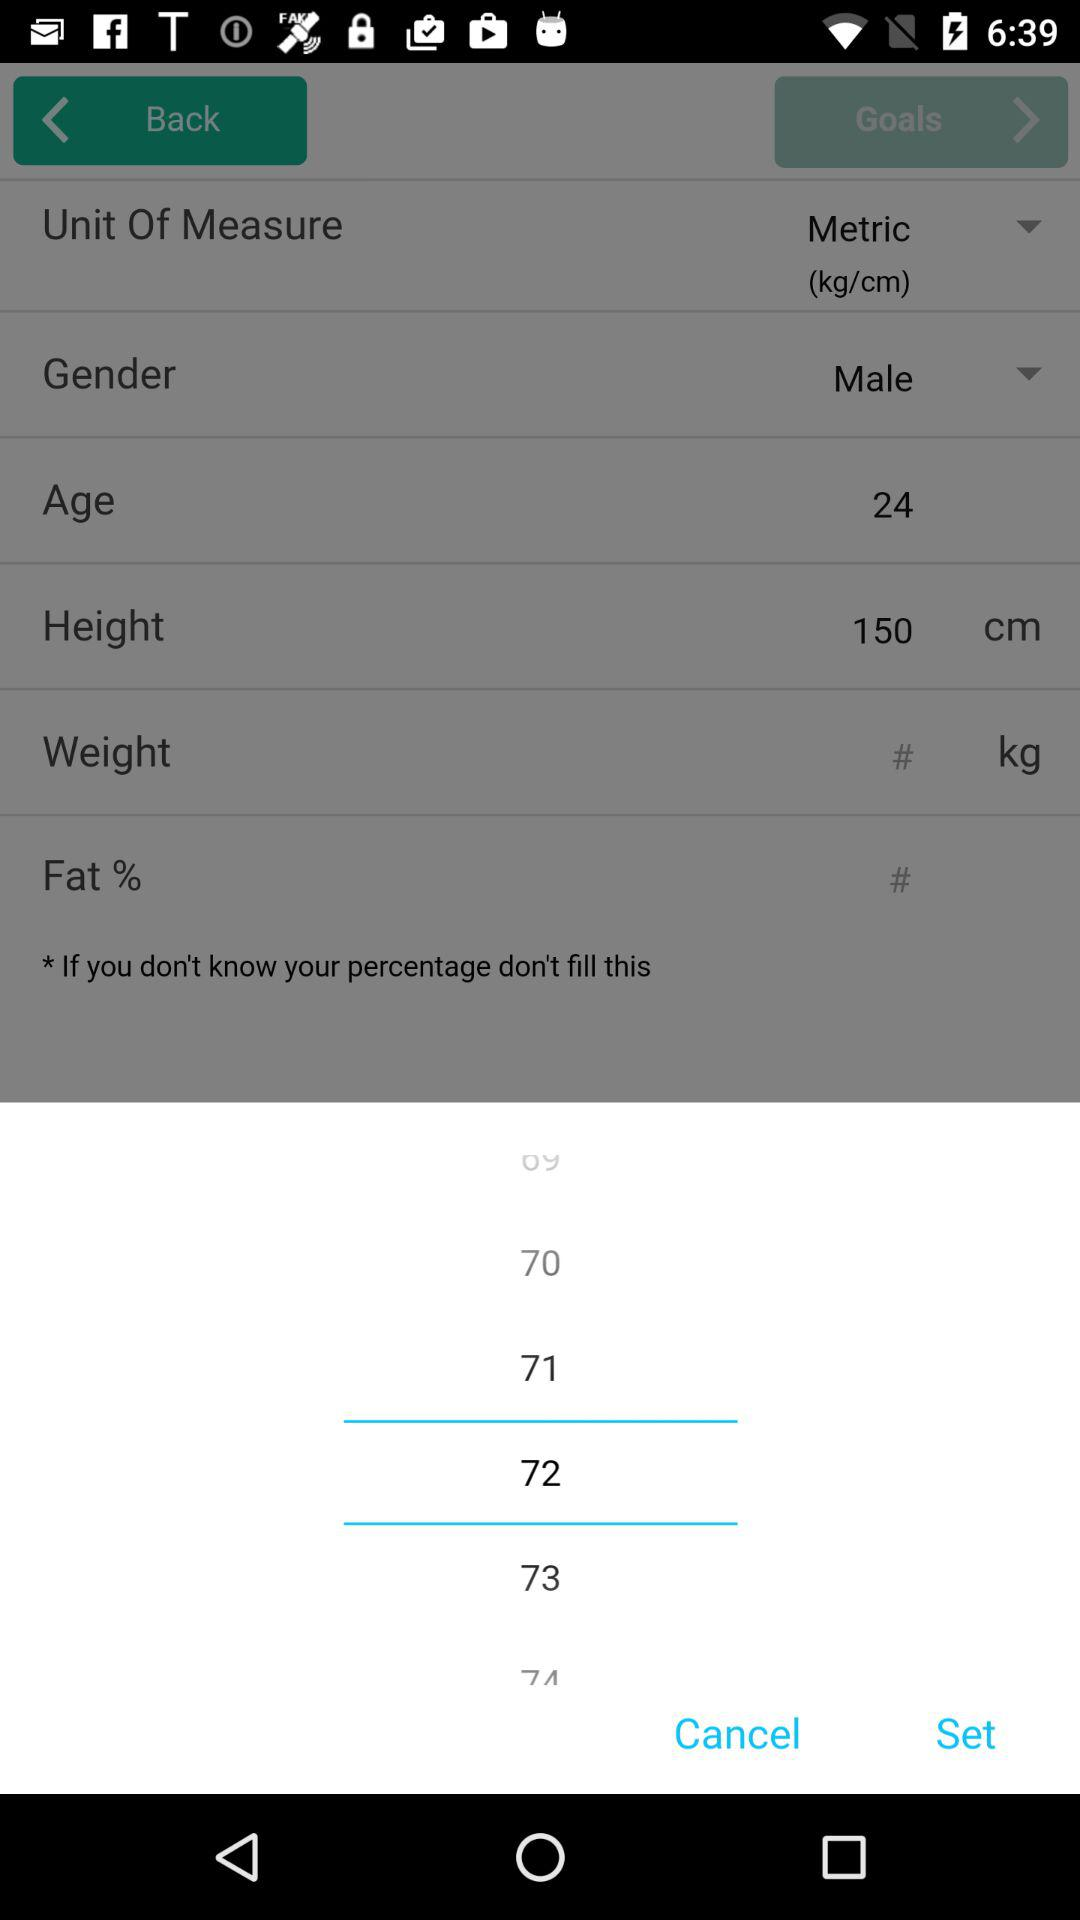How many options are there for the unit of measure?
Answer the question using a single word or phrase. 1 